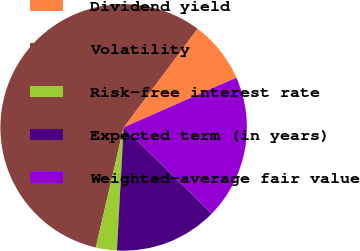Convert chart to OTSL. <chart><loc_0><loc_0><loc_500><loc_500><pie_chart><fcel>Dividend yield<fcel>Volatility<fcel>Risk-free interest rate<fcel>Expected term (in years)<fcel>Weighted-average fair value<nl><fcel>8.16%<fcel>56.6%<fcel>2.76%<fcel>13.55%<fcel>18.94%<nl></chart> 